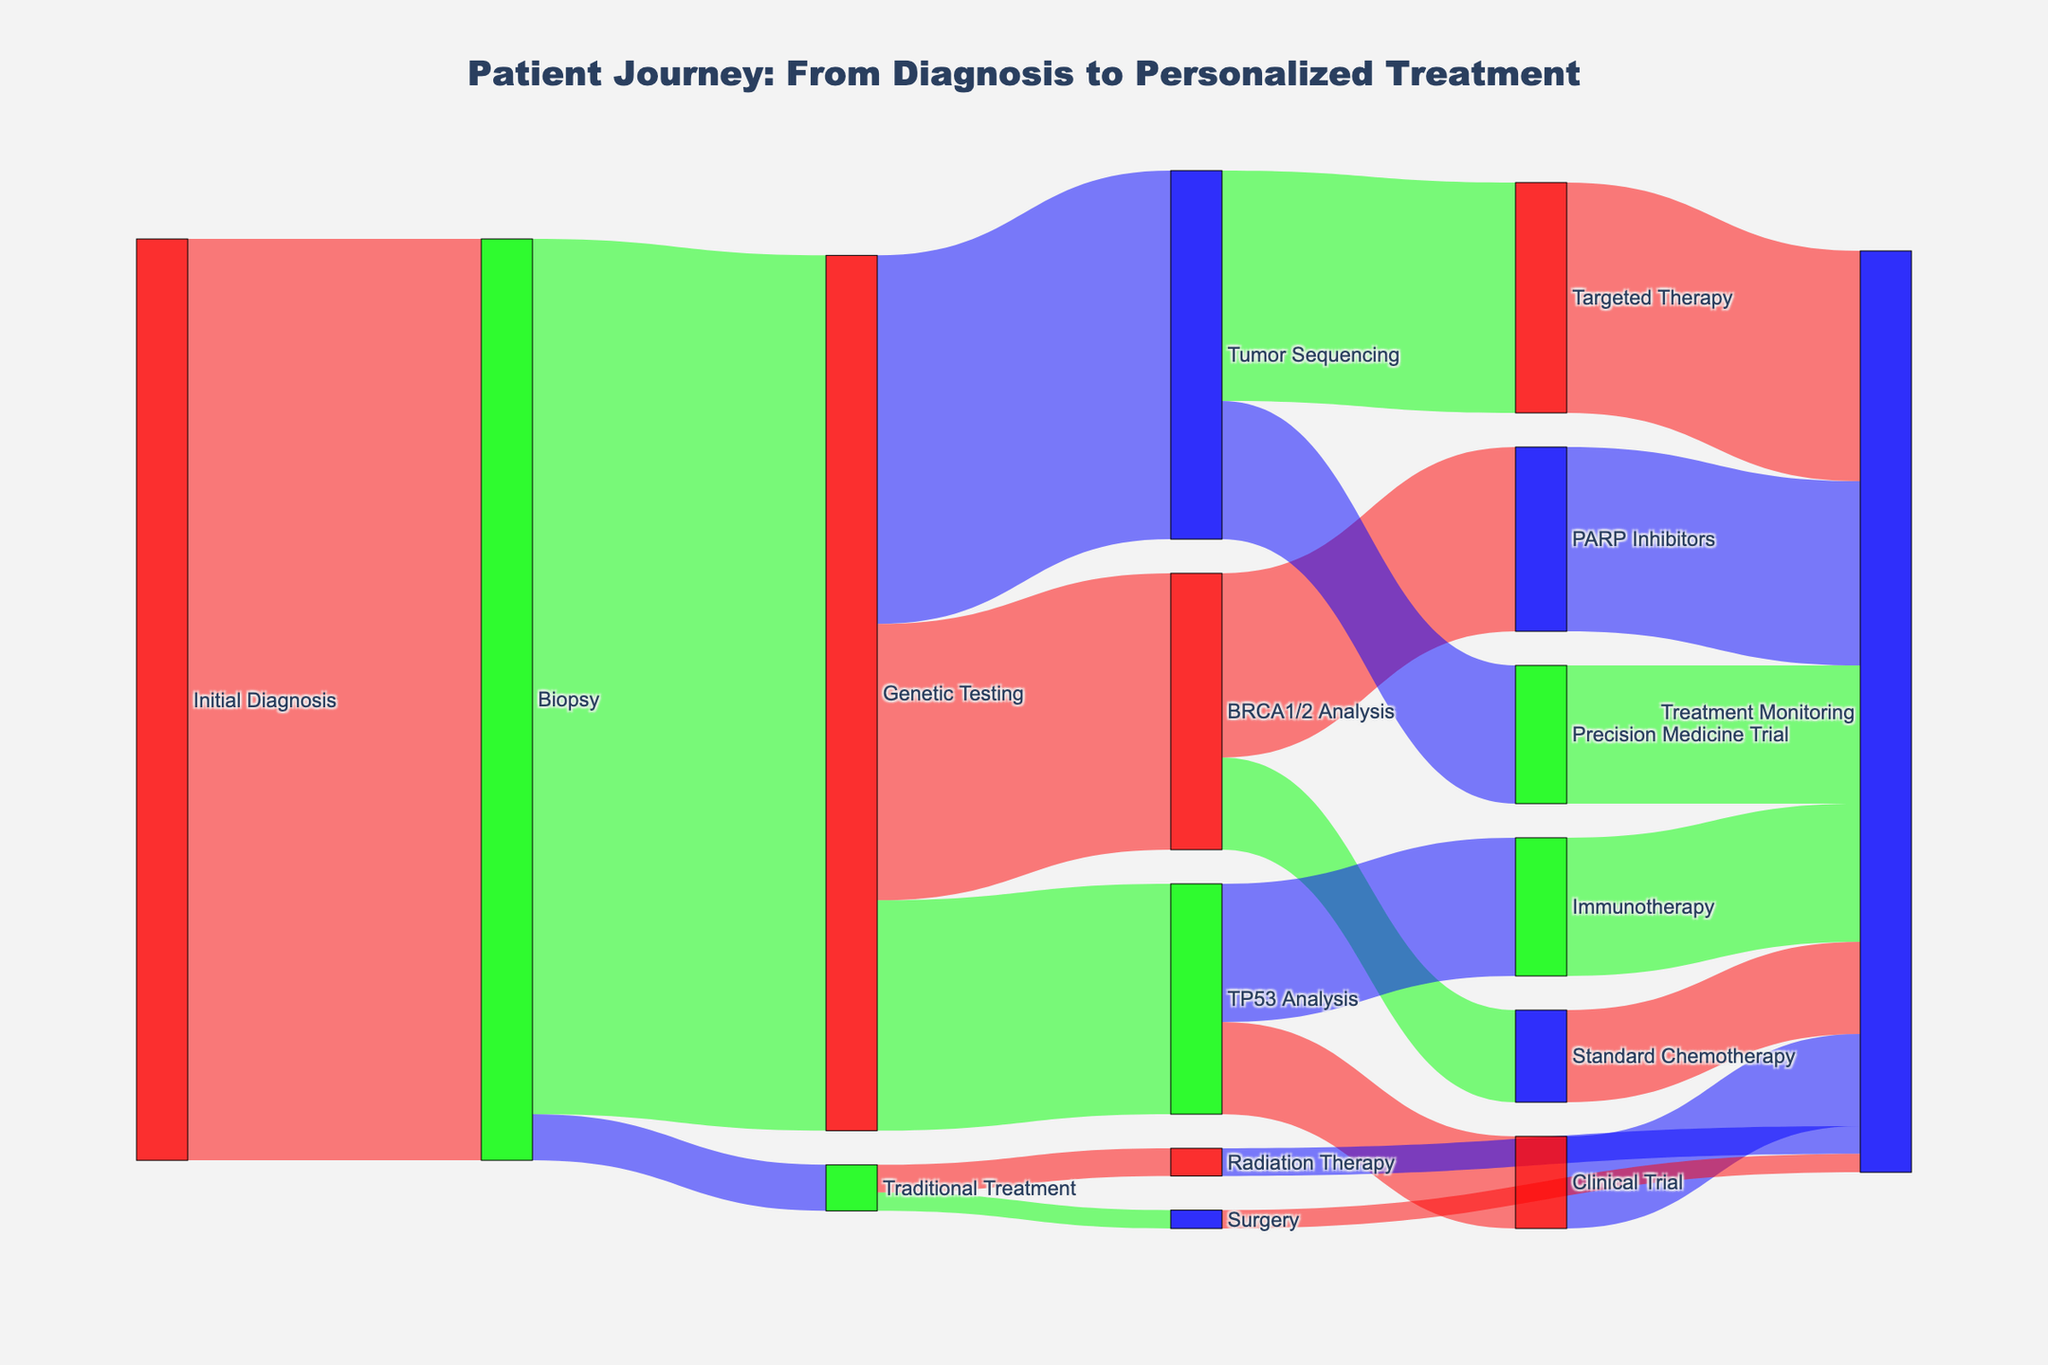How many patients received Biopsy after their Initial Diagnosis? The link from "Initial Diagnosis" to "Biopsy" shows a value of 100, indicating that 100 patients received a biopsy after their initial diagnosis.
Answer: 100 How many patients proceeded to Traditional Treatment after a Biopsy? The link from "Biopsy" to "Traditional Treatment" shows a value of 5, indicating that 5 patients proceeded to traditional treatment after a biopsy.
Answer: 5 Which type of Genetic Testing was performed on the highest number of patients? The links from "Genetic Testing" show different values: BRCA1/2 Analysis (30), TP53 Analysis (25), and Tumor Sequencing (40). Tumor Sequencing has the highest value.
Answer: Tumor Sequencing How many patients received PARP Inhibitors after BRCA1/2 Analysis? The link from "BRCA1/2 Analysis" to "PARP Inhibitors" shows a value of 20, indicating that 20 patients received PARP Inhibitors.
Answer: 20 What is the total number of patients that underwent Treatment Monitoring after receiving Traditional Treatment? Sum the values from "Radiation Therapy" (3) and "Surgery" (2) leading to Treatment Monitoring: 3 + 2 = 5.
Answer: 5 Compare the number of patients who received Targeted Therapy to those in Precision Medicine Trial after Tumor Sequencing. Which group is larger? Targeted Therapy has a value of 25 and Precision Medicine Trial has a value of 15. Targeted Therapy is larger.
Answer: Targeted Therapy What fraction of patients conducted BRCA1/2 Analysis opted for Standard Chemotherapy? Out of 30 patients who conducted BRCA1/2 Analysis, 10 opted for Standard Chemotherapy. The fraction is 10/30 = 1/3.
Answer: 1/3 How many patients underwent Genetic Testing after a Biopsy and what percentage of these proceeded to Tumor Sequencing? 95 patients underwent Genetic Testing after a Biopsy. Out of these, 40 proceeded to Tumor Sequencing. The percentage is (40/95) * 100 ≈ 42.11%.
Answer: 42.11% Which treatment option after TP53 Analysis had fewer patients, Immunotherapy or Clinical Trial? The link from "TP53 Analysis" to "Immunotherapy" has a value of 15, and "Clinical Trial" has a value of 10. Clinical Trial had fewer patients.
Answer: Clinical Trial 